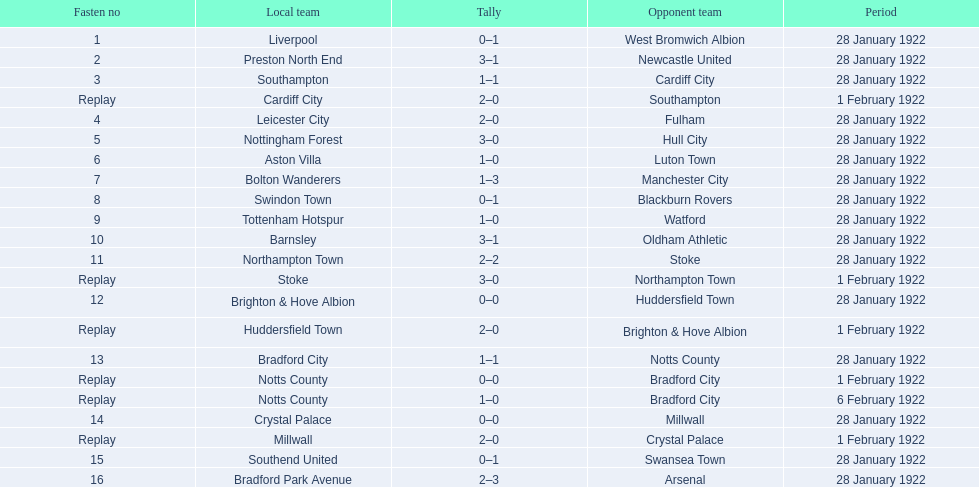Which game had a higher total number of goals scored, 1 or 16? 16. Can you parse all the data within this table? {'header': ['Fasten no', 'Local team', 'Tally', 'Opponent team', 'Period'], 'rows': [['1', 'Liverpool', '0–1', 'West Bromwich Albion', '28 January 1922'], ['2', 'Preston North End', '3–1', 'Newcastle United', '28 January 1922'], ['3', 'Southampton', '1–1', 'Cardiff City', '28 January 1922'], ['Replay', 'Cardiff City', '2–0', 'Southampton', '1 February 1922'], ['4', 'Leicester City', '2–0', 'Fulham', '28 January 1922'], ['5', 'Nottingham Forest', '3–0', 'Hull City', '28 January 1922'], ['6', 'Aston Villa', '1–0', 'Luton Town', '28 January 1922'], ['7', 'Bolton Wanderers', '1–3', 'Manchester City', '28 January 1922'], ['8', 'Swindon Town', '0–1', 'Blackburn Rovers', '28 January 1922'], ['9', 'Tottenham Hotspur', '1–0', 'Watford', '28 January 1922'], ['10', 'Barnsley', '3–1', 'Oldham Athletic', '28 January 1922'], ['11', 'Northampton Town', '2–2', 'Stoke', '28 January 1922'], ['Replay', 'Stoke', '3–0', 'Northampton Town', '1 February 1922'], ['12', 'Brighton & Hove Albion', '0–0', 'Huddersfield Town', '28 January 1922'], ['Replay', 'Huddersfield Town', '2–0', 'Brighton & Hove Albion', '1 February 1922'], ['13', 'Bradford City', '1–1', 'Notts County', '28 January 1922'], ['Replay', 'Notts County', '0–0', 'Bradford City', '1 February 1922'], ['Replay', 'Notts County', '1–0', 'Bradford City', '6 February 1922'], ['14', 'Crystal Palace', '0–0', 'Millwall', '28 January 1922'], ['Replay', 'Millwall', '2–0', 'Crystal Palace', '1 February 1922'], ['15', 'Southend United', '0–1', 'Swansea Town', '28 January 1922'], ['16', 'Bradford Park Avenue', '2–3', 'Arsenal', '28 January 1922']]} 